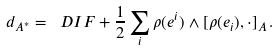<formula> <loc_0><loc_0><loc_500><loc_500>d _ { A ^ { * } } = \ D I F + \frac { 1 } { 2 } \sum _ { i } \rho ( e ^ { i } ) \wedge [ \rho ( e _ { i } ) , \cdot ] _ { A } \, .</formula> 